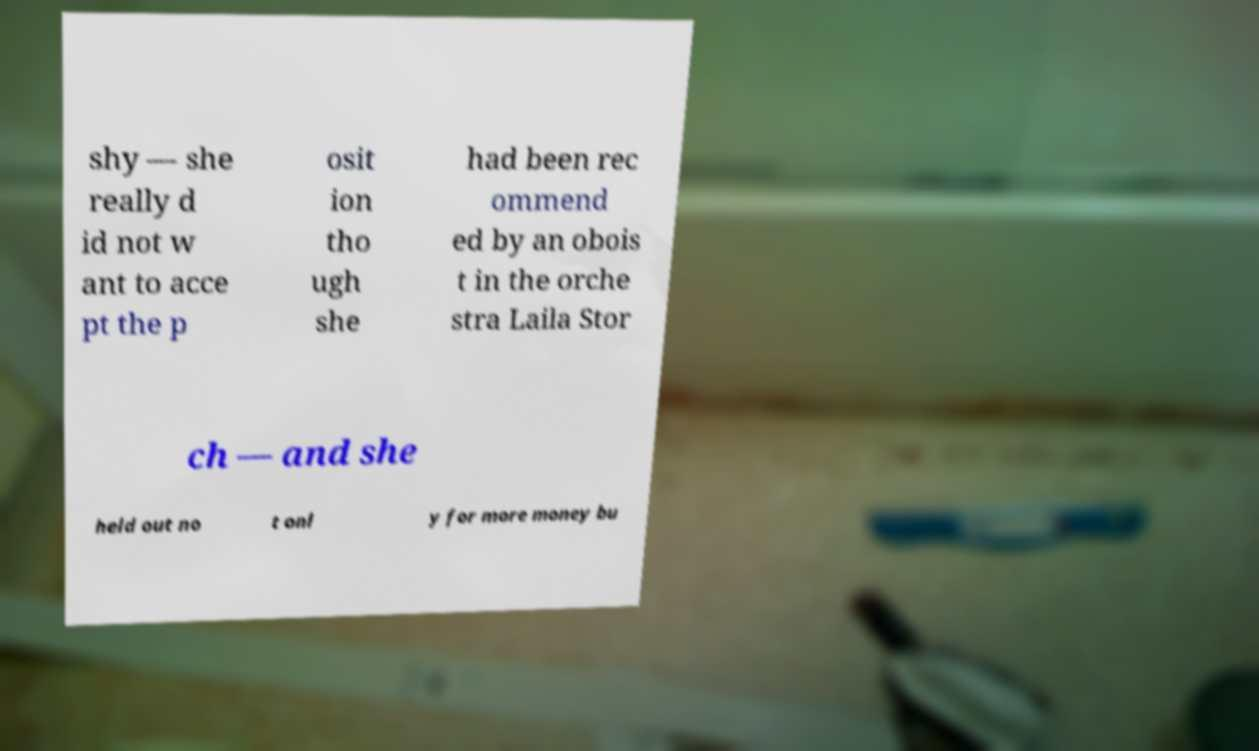Can you accurately transcribe the text from the provided image for me? shy — she really d id not w ant to acce pt the p osit ion tho ugh she had been rec ommend ed by an obois t in the orche stra Laila Stor ch — and she held out no t onl y for more money bu 